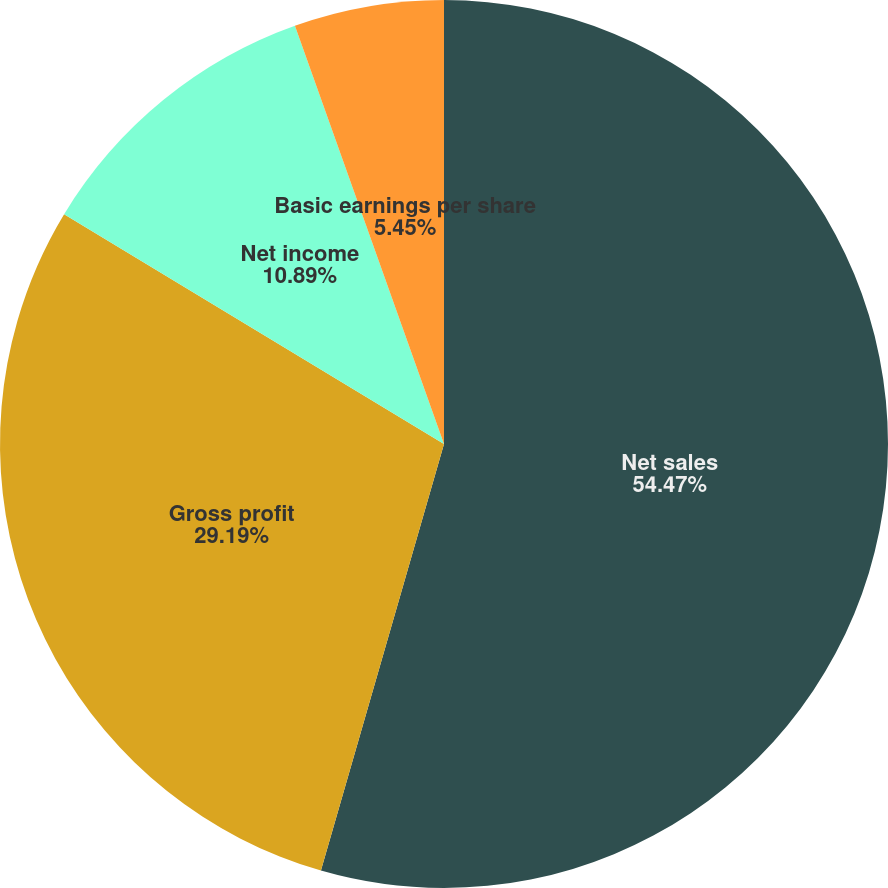<chart> <loc_0><loc_0><loc_500><loc_500><pie_chart><fcel>Net sales<fcel>Gross profit<fcel>Net income<fcel>Basic earnings per share<fcel>Diluted earnings per share<nl><fcel>54.47%<fcel>29.19%<fcel>10.89%<fcel>5.45%<fcel>0.0%<nl></chart> 